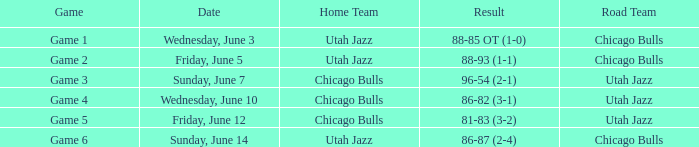Road Team of utah jazz, and a Result of 81-83 (3-2) involved what game? Game 5. 